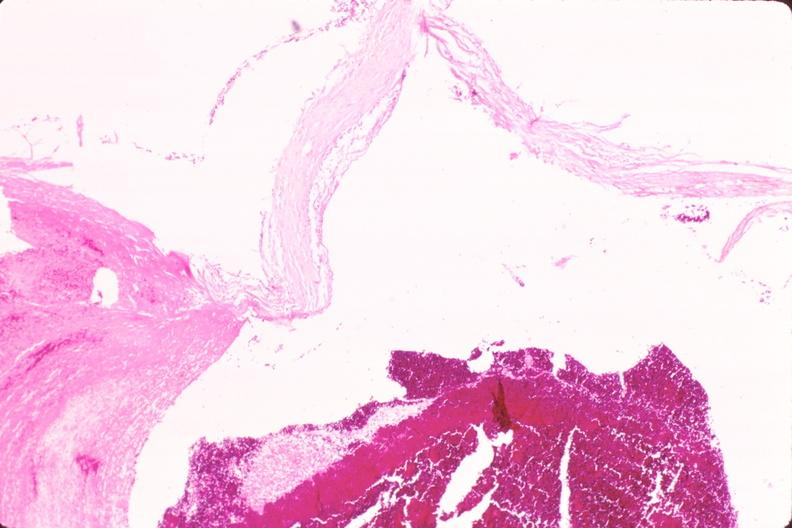s capillary present?
Answer the question using a single word or phrase. No 